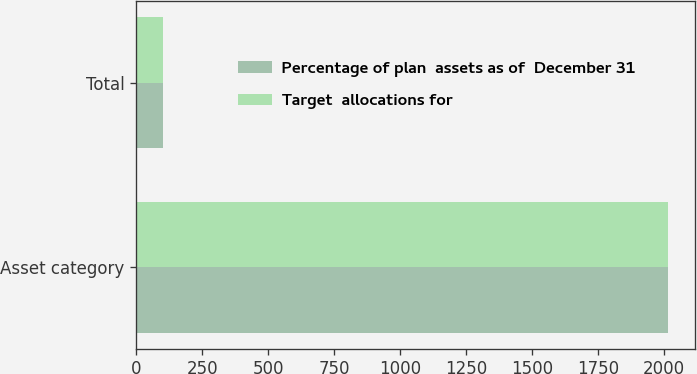Convert chart. <chart><loc_0><loc_0><loc_500><loc_500><stacked_bar_chart><ecel><fcel>Asset category<fcel>Total<nl><fcel>Percentage of plan  assets as of  December 31<fcel>2017<fcel>100<nl><fcel>Target  allocations for<fcel>2016<fcel>100<nl></chart> 